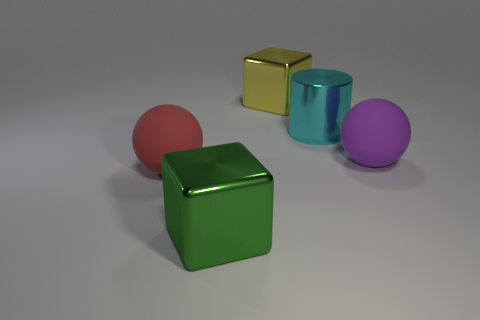Add 2 large cyan cylinders. How many objects exist? 7 Subtract all blocks. How many objects are left? 3 Add 4 big yellow shiny balls. How many big yellow shiny balls exist? 4 Subtract 1 red balls. How many objects are left? 4 Subtract all tiny blue balls. Subtract all matte objects. How many objects are left? 3 Add 2 large green shiny cubes. How many large green shiny cubes are left? 3 